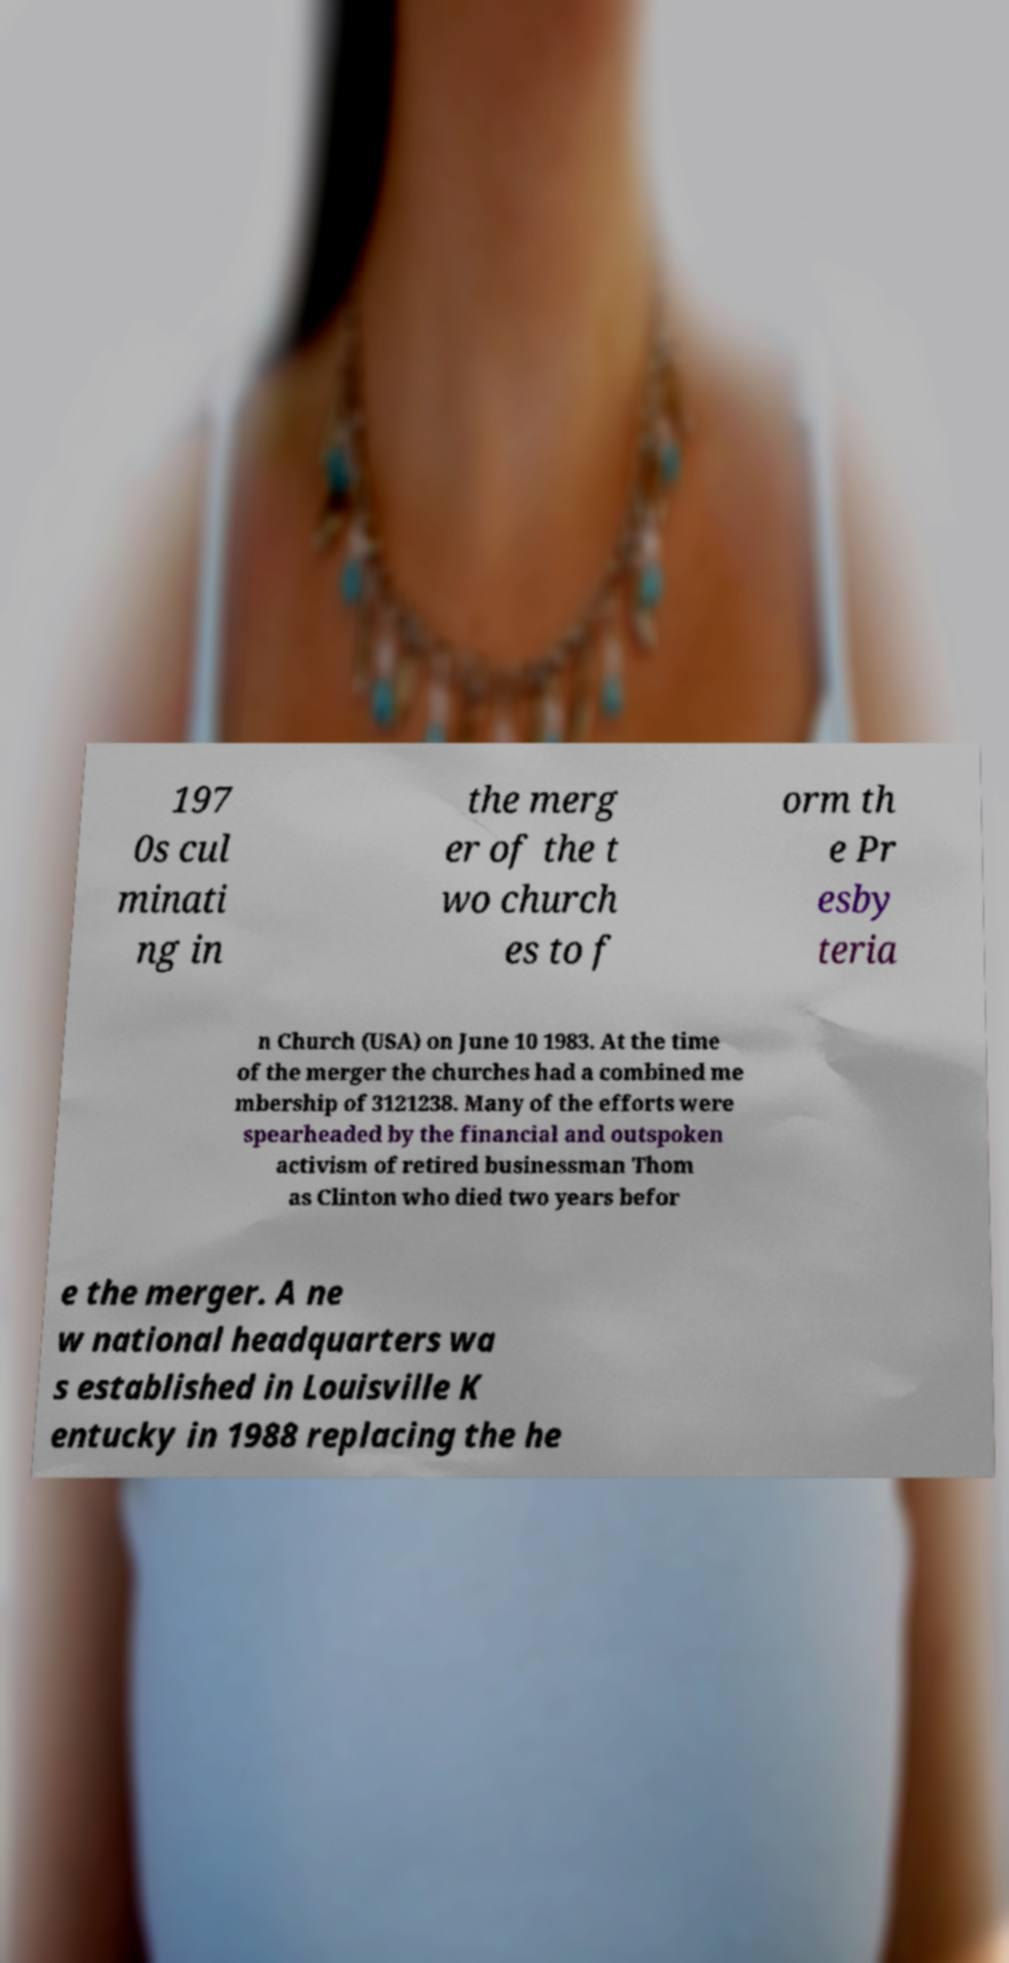Could you assist in decoding the text presented in this image and type it out clearly? 197 0s cul minati ng in the merg er of the t wo church es to f orm th e Pr esby teria n Church (USA) on June 10 1983. At the time of the merger the churches had a combined me mbership of 3121238. Many of the efforts were spearheaded by the financial and outspoken activism of retired businessman Thom as Clinton who died two years befor e the merger. A ne w national headquarters wa s established in Louisville K entucky in 1988 replacing the he 